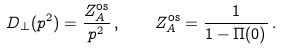Convert formula to latex. <formula><loc_0><loc_0><loc_500><loc_500>D _ { \bot } ( p ^ { 2 } ) = \frac { Z _ { A } ^ { \text {os} } } { p ^ { 2 } } \, , \quad Z _ { A } ^ { \text {os} } = \frac { 1 } { 1 - \Pi ( 0 ) } \, .</formula> 